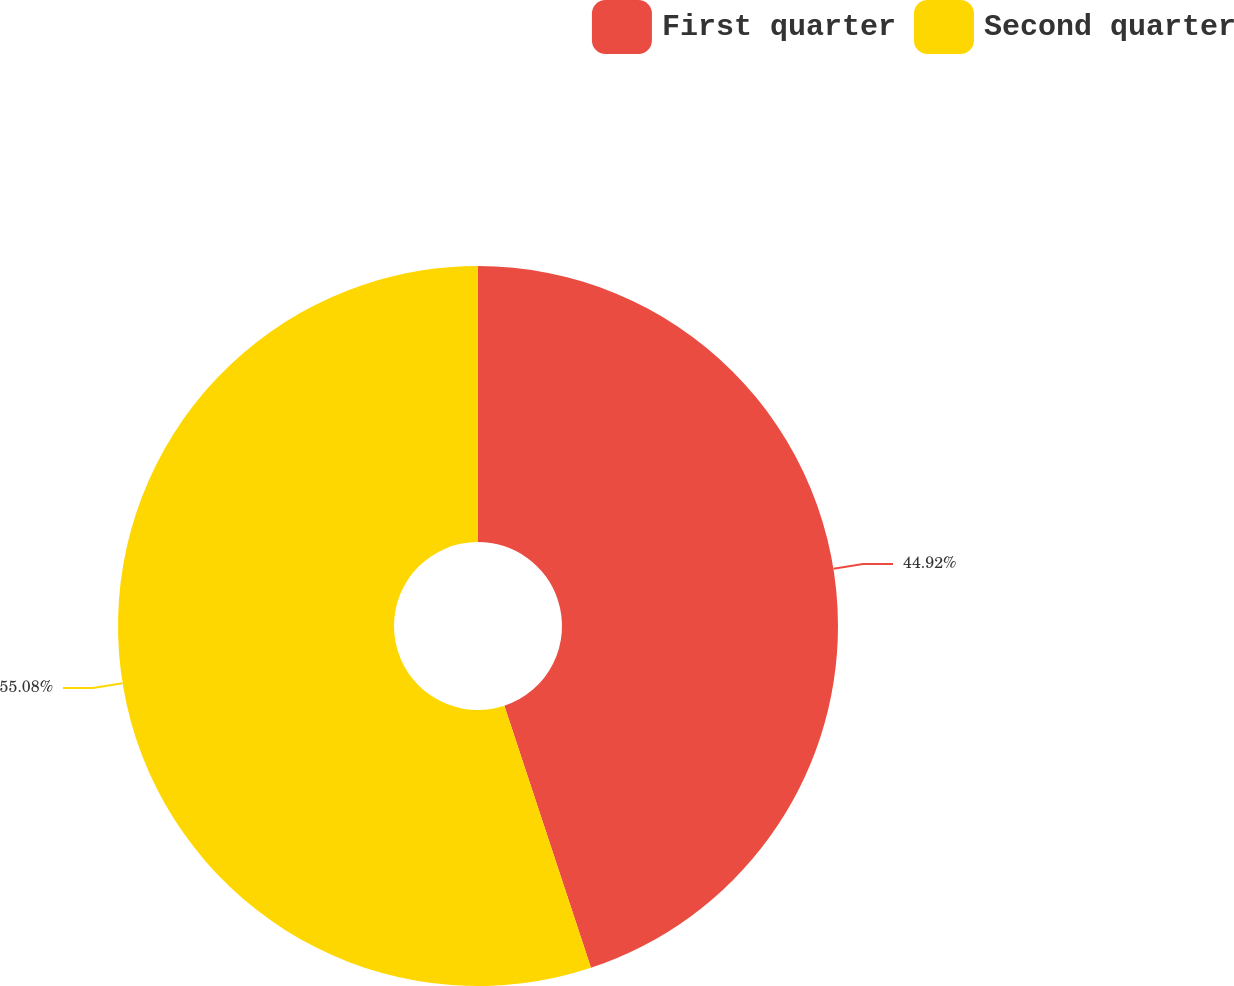Convert chart to OTSL. <chart><loc_0><loc_0><loc_500><loc_500><pie_chart><fcel>First quarter<fcel>Second quarter<nl><fcel>44.92%<fcel>55.08%<nl></chart> 